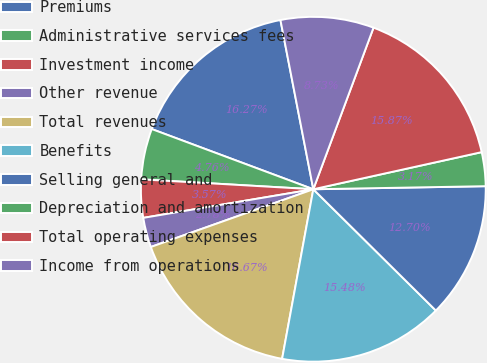Convert chart. <chart><loc_0><loc_0><loc_500><loc_500><pie_chart><fcel>Premiums<fcel>Administrative services fees<fcel>Investment income<fcel>Other revenue<fcel>Total revenues<fcel>Benefits<fcel>Selling general and<fcel>Depreciation and amortization<fcel>Total operating expenses<fcel>Income from operations<nl><fcel>16.27%<fcel>4.76%<fcel>3.57%<fcel>2.78%<fcel>16.67%<fcel>15.48%<fcel>12.7%<fcel>3.17%<fcel>15.87%<fcel>8.73%<nl></chart> 